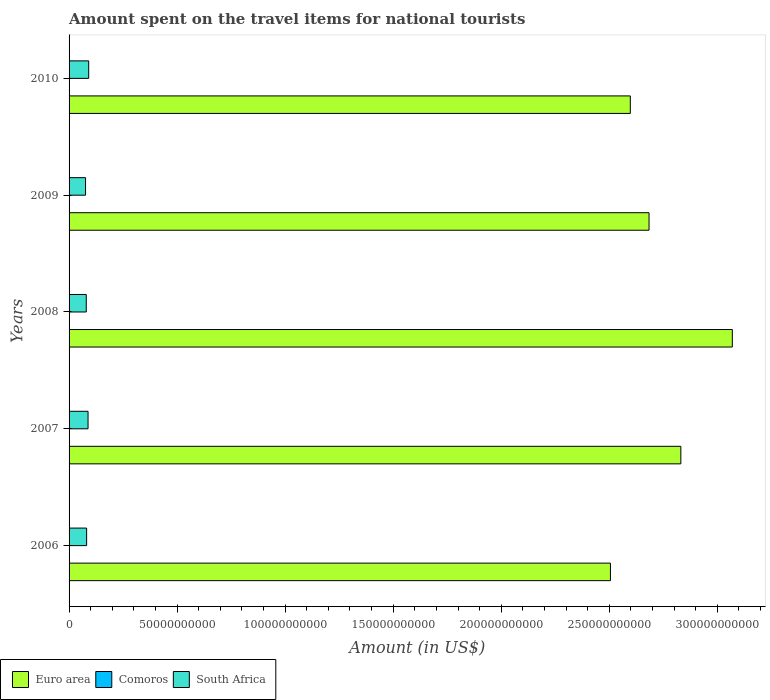How many different coloured bars are there?
Give a very brief answer. 3. How many groups of bars are there?
Offer a terse response. 5. Are the number of bars on each tick of the Y-axis equal?
Your answer should be compact. Yes. How many bars are there on the 1st tick from the top?
Give a very brief answer. 3. What is the label of the 4th group of bars from the top?
Provide a short and direct response. 2007. In how many cases, is the number of bars for a given year not equal to the number of legend labels?
Provide a succinct answer. 0. What is the amount spent on the travel items for national tourists in Comoros in 2010?
Your answer should be very brief. 3.50e+07. Across all years, what is the maximum amount spent on the travel items for national tourists in Comoros?
Provide a succinct answer. 3.70e+07. Across all years, what is the minimum amount spent on the travel items for national tourists in South Africa?
Ensure brevity in your answer.  7.62e+09. In which year was the amount spent on the travel items for national tourists in South Africa minimum?
Offer a terse response. 2009. What is the total amount spent on the travel items for national tourists in South Africa in the graph?
Provide a short and direct response. 4.16e+1. What is the difference between the amount spent on the travel items for national tourists in South Africa in 2006 and that in 2007?
Ensure brevity in your answer.  -6.59e+08. What is the difference between the amount spent on the travel items for national tourists in Euro area in 2009 and the amount spent on the travel items for national tourists in Comoros in 2008?
Ensure brevity in your answer.  2.68e+11. What is the average amount spent on the travel items for national tourists in Comoros per year?
Your response must be concise. 3.22e+07. In the year 2006, what is the difference between the amount spent on the travel items for national tourists in Euro area and amount spent on the travel items for national tourists in South Africa?
Provide a short and direct response. 2.42e+11. In how many years, is the amount spent on the travel items for national tourists in Comoros greater than 230000000000 US$?
Ensure brevity in your answer.  0. What is the ratio of the amount spent on the travel items for national tourists in Comoros in 2007 to that in 2010?
Your response must be concise. 0.86. Is the amount spent on the travel items for national tourists in Euro area in 2009 less than that in 2010?
Give a very brief answer. No. Is the difference between the amount spent on the travel items for national tourists in Euro area in 2006 and 2010 greater than the difference between the amount spent on the travel items for national tourists in South Africa in 2006 and 2010?
Offer a very short reply. No. What is the difference between the highest and the second highest amount spent on the travel items for national tourists in Euro area?
Make the answer very short. 2.38e+1. What is the difference between the highest and the lowest amount spent on the travel items for national tourists in South Africa?
Your answer should be very brief. 1.46e+09. In how many years, is the amount spent on the travel items for national tourists in South Africa greater than the average amount spent on the travel items for national tourists in South Africa taken over all years?
Your response must be concise. 2. Is the sum of the amount spent on the travel items for national tourists in Comoros in 2009 and 2010 greater than the maximum amount spent on the travel items for national tourists in South Africa across all years?
Your answer should be compact. No. What does the 2nd bar from the top in 2006 represents?
Your answer should be compact. Comoros. Is it the case that in every year, the sum of the amount spent on the travel items for national tourists in Comoros and amount spent on the travel items for national tourists in Euro area is greater than the amount spent on the travel items for national tourists in South Africa?
Ensure brevity in your answer.  Yes. How many bars are there?
Offer a very short reply. 15. Are the values on the major ticks of X-axis written in scientific E-notation?
Provide a short and direct response. No. Does the graph contain any zero values?
Provide a short and direct response. No. Does the graph contain grids?
Make the answer very short. No. Where does the legend appear in the graph?
Provide a short and direct response. Bottom left. How many legend labels are there?
Provide a succinct answer. 3. What is the title of the graph?
Ensure brevity in your answer.  Amount spent on the travel items for national tourists. Does "Seychelles" appear as one of the legend labels in the graph?
Offer a very short reply. No. What is the Amount (in US$) in Euro area in 2006?
Provide a short and direct response. 2.51e+11. What is the Amount (in US$) of Comoros in 2006?
Give a very brief answer. 2.70e+07. What is the Amount (in US$) of South Africa in 2006?
Provide a succinct answer. 8.12e+09. What is the Amount (in US$) in Euro area in 2007?
Provide a succinct answer. 2.83e+11. What is the Amount (in US$) of Comoros in 2007?
Provide a succinct answer. 3.00e+07. What is the Amount (in US$) in South Africa in 2007?
Ensure brevity in your answer.  8.78e+09. What is the Amount (in US$) of Euro area in 2008?
Give a very brief answer. 3.07e+11. What is the Amount (in US$) of Comoros in 2008?
Offer a terse response. 3.70e+07. What is the Amount (in US$) of South Africa in 2008?
Your answer should be very brief. 7.96e+09. What is the Amount (in US$) in Euro area in 2009?
Keep it short and to the point. 2.68e+11. What is the Amount (in US$) in Comoros in 2009?
Your answer should be very brief. 3.20e+07. What is the Amount (in US$) of South Africa in 2009?
Your answer should be very brief. 7.62e+09. What is the Amount (in US$) of Euro area in 2010?
Offer a terse response. 2.60e+11. What is the Amount (in US$) in Comoros in 2010?
Your response must be concise. 3.50e+07. What is the Amount (in US$) of South Africa in 2010?
Provide a succinct answer. 9.08e+09. Across all years, what is the maximum Amount (in US$) of Euro area?
Your answer should be compact. 3.07e+11. Across all years, what is the maximum Amount (in US$) of Comoros?
Make the answer very short. 3.70e+07. Across all years, what is the maximum Amount (in US$) in South Africa?
Ensure brevity in your answer.  9.08e+09. Across all years, what is the minimum Amount (in US$) in Euro area?
Provide a short and direct response. 2.51e+11. Across all years, what is the minimum Amount (in US$) of Comoros?
Keep it short and to the point. 2.70e+07. Across all years, what is the minimum Amount (in US$) of South Africa?
Keep it short and to the point. 7.62e+09. What is the total Amount (in US$) of Euro area in the graph?
Offer a very short reply. 1.37e+12. What is the total Amount (in US$) of Comoros in the graph?
Give a very brief answer. 1.61e+08. What is the total Amount (in US$) of South Africa in the graph?
Your answer should be compact. 4.16e+1. What is the difference between the Amount (in US$) of Euro area in 2006 and that in 2007?
Offer a terse response. -3.26e+1. What is the difference between the Amount (in US$) in Comoros in 2006 and that in 2007?
Provide a succinct answer. -3.00e+06. What is the difference between the Amount (in US$) of South Africa in 2006 and that in 2007?
Give a very brief answer. -6.59e+08. What is the difference between the Amount (in US$) of Euro area in 2006 and that in 2008?
Provide a short and direct response. -5.64e+1. What is the difference between the Amount (in US$) in Comoros in 2006 and that in 2008?
Provide a short and direct response. -1.00e+07. What is the difference between the Amount (in US$) in South Africa in 2006 and that in 2008?
Provide a succinct answer. 1.64e+08. What is the difference between the Amount (in US$) of Euro area in 2006 and that in 2009?
Provide a short and direct response. -1.79e+1. What is the difference between the Amount (in US$) in Comoros in 2006 and that in 2009?
Your answer should be very brief. -5.00e+06. What is the difference between the Amount (in US$) in South Africa in 2006 and that in 2009?
Your response must be concise. 4.96e+08. What is the difference between the Amount (in US$) in Euro area in 2006 and that in 2010?
Your answer should be compact. -9.19e+09. What is the difference between the Amount (in US$) of Comoros in 2006 and that in 2010?
Your answer should be very brief. -8.00e+06. What is the difference between the Amount (in US$) in South Africa in 2006 and that in 2010?
Your response must be concise. -9.65e+08. What is the difference between the Amount (in US$) of Euro area in 2007 and that in 2008?
Your response must be concise. -2.38e+1. What is the difference between the Amount (in US$) of Comoros in 2007 and that in 2008?
Offer a terse response. -7.00e+06. What is the difference between the Amount (in US$) in South Africa in 2007 and that in 2008?
Your response must be concise. 8.23e+08. What is the difference between the Amount (in US$) of Euro area in 2007 and that in 2009?
Your answer should be compact. 1.47e+1. What is the difference between the Amount (in US$) of Comoros in 2007 and that in 2009?
Offer a terse response. -2.00e+06. What is the difference between the Amount (in US$) of South Africa in 2007 and that in 2009?
Give a very brief answer. 1.16e+09. What is the difference between the Amount (in US$) in Euro area in 2007 and that in 2010?
Make the answer very short. 2.34e+1. What is the difference between the Amount (in US$) in Comoros in 2007 and that in 2010?
Offer a terse response. -5.00e+06. What is the difference between the Amount (in US$) in South Africa in 2007 and that in 2010?
Your answer should be compact. -3.06e+08. What is the difference between the Amount (in US$) in Euro area in 2008 and that in 2009?
Give a very brief answer. 3.85e+1. What is the difference between the Amount (in US$) in South Africa in 2008 and that in 2009?
Make the answer very short. 3.32e+08. What is the difference between the Amount (in US$) of Euro area in 2008 and that in 2010?
Your response must be concise. 4.72e+1. What is the difference between the Amount (in US$) in Comoros in 2008 and that in 2010?
Provide a succinct answer. 2.00e+06. What is the difference between the Amount (in US$) in South Africa in 2008 and that in 2010?
Provide a succinct answer. -1.13e+09. What is the difference between the Amount (in US$) in Euro area in 2009 and that in 2010?
Your answer should be compact. 8.67e+09. What is the difference between the Amount (in US$) of South Africa in 2009 and that in 2010?
Provide a short and direct response. -1.46e+09. What is the difference between the Amount (in US$) in Euro area in 2006 and the Amount (in US$) in Comoros in 2007?
Provide a short and direct response. 2.51e+11. What is the difference between the Amount (in US$) in Euro area in 2006 and the Amount (in US$) in South Africa in 2007?
Ensure brevity in your answer.  2.42e+11. What is the difference between the Amount (in US$) of Comoros in 2006 and the Amount (in US$) of South Africa in 2007?
Provide a short and direct response. -8.75e+09. What is the difference between the Amount (in US$) of Euro area in 2006 and the Amount (in US$) of Comoros in 2008?
Your answer should be very brief. 2.50e+11. What is the difference between the Amount (in US$) in Euro area in 2006 and the Amount (in US$) in South Africa in 2008?
Your response must be concise. 2.43e+11. What is the difference between the Amount (in US$) in Comoros in 2006 and the Amount (in US$) in South Africa in 2008?
Keep it short and to the point. -7.93e+09. What is the difference between the Amount (in US$) of Euro area in 2006 and the Amount (in US$) of Comoros in 2009?
Provide a short and direct response. 2.50e+11. What is the difference between the Amount (in US$) in Euro area in 2006 and the Amount (in US$) in South Africa in 2009?
Provide a succinct answer. 2.43e+11. What is the difference between the Amount (in US$) of Comoros in 2006 and the Amount (in US$) of South Africa in 2009?
Your answer should be very brief. -7.60e+09. What is the difference between the Amount (in US$) in Euro area in 2006 and the Amount (in US$) in Comoros in 2010?
Keep it short and to the point. 2.50e+11. What is the difference between the Amount (in US$) in Euro area in 2006 and the Amount (in US$) in South Africa in 2010?
Provide a short and direct response. 2.41e+11. What is the difference between the Amount (in US$) in Comoros in 2006 and the Amount (in US$) in South Africa in 2010?
Offer a terse response. -9.06e+09. What is the difference between the Amount (in US$) in Euro area in 2007 and the Amount (in US$) in Comoros in 2008?
Your answer should be very brief. 2.83e+11. What is the difference between the Amount (in US$) in Euro area in 2007 and the Amount (in US$) in South Africa in 2008?
Offer a terse response. 2.75e+11. What is the difference between the Amount (in US$) in Comoros in 2007 and the Amount (in US$) in South Africa in 2008?
Your response must be concise. -7.93e+09. What is the difference between the Amount (in US$) of Euro area in 2007 and the Amount (in US$) of Comoros in 2009?
Give a very brief answer. 2.83e+11. What is the difference between the Amount (in US$) of Euro area in 2007 and the Amount (in US$) of South Africa in 2009?
Offer a very short reply. 2.75e+11. What is the difference between the Amount (in US$) in Comoros in 2007 and the Amount (in US$) in South Africa in 2009?
Provide a succinct answer. -7.59e+09. What is the difference between the Amount (in US$) in Euro area in 2007 and the Amount (in US$) in Comoros in 2010?
Your answer should be compact. 2.83e+11. What is the difference between the Amount (in US$) of Euro area in 2007 and the Amount (in US$) of South Africa in 2010?
Offer a very short reply. 2.74e+11. What is the difference between the Amount (in US$) in Comoros in 2007 and the Amount (in US$) in South Africa in 2010?
Offer a terse response. -9.06e+09. What is the difference between the Amount (in US$) in Euro area in 2008 and the Amount (in US$) in Comoros in 2009?
Offer a very short reply. 3.07e+11. What is the difference between the Amount (in US$) in Euro area in 2008 and the Amount (in US$) in South Africa in 2009?
Your answer should be very brief. 2.99e+11. What is the difference between the Amount (in US$) of Comoros in 2008 and the Amount (in US$) of South Africa in 2009?
Make the answer very short. -7.59e+09. What is the difference between the Amount (in US$) in Euro area in 2008 and the Amount (in US$) in Comoros in 2010?
Give a very brief answer. 3.07e+11. What is the difference between the Amount (in US$) in Euro area in 2008 and the Amount (in US$) in South Africa in 2010?
Your answer should be compact. 2.98e+11. What is the difference between the Amount (in US$) in Comoros in 2008 and the Amount (in US$) in South Africa in 2010?
Provide a short and direct response. -9.05e+09. What is the difference between the Amount (in US$) of Euro area in 2009 and the Amount (in US$) of Comoros in 2010?
Provide a succinct answer. 2.68e+11. What is the difference between the Amount (in US$) of Euro area in 2009 and the Amount (in US$) of South Africa in 2010?
Your answer should be very brief. 2.59e+11. What is the difference between the Amount (in US$) of Comoros in 2009 and the Amount (in US$) of South Africa in 2010?
Ensure brevity in your answer.  -9.05e+09. What is the average Amount (in US$) in Euro area per year?
Offer a very short reply. 2.74e+11. What is the average Amount (in US$) in Comoros per year?
Provide a short and direct response. 3.22e+07. What is the average Amount (in US$) of South Africa per year?
Provide a succinct answer. 8.31e+09. In the year 2006, what is the difference between the Amount (in US$) in Euro area and Amount (in US$) in Comoros?
Provide a short and direct response. 2.51e+11. In the year 2006, what is the difference between the Amount (in US$) of Euro area and Amount (in US$) of South Africa?
Offer a terse response. 2.42e+11. In the year 2006, what is the difference between the Amount (in US$) of Comoros and Amount (in US$) of South Africa?
Offer a very short reply. -8.09e+09. In the year 2007, what is the difference between the Amount (in US$) in Euro area and Amount (in US$) in Comoros?
Your answer should be compact. 2.83e+11. In the year 2007, what is the difference between the Amount (in US$) in Euro area and Amount (in US$) in South Africa?
Give a very brief answer. 2.74e+11. In the year 2007, what is the difference between the Amount (in US$) in Comoros and Amount (in US$) in South Africa?
Your response must be concise. -8.75e+09. In the year 2008, what is the difference between the Amount (in US$) of Euro area and Amount (in US$) of Comoros?
Keep it short and to the point. 3.07e+11. In the year 2008, what is the difference between the Amount (in US$) in Euro area and Amount (in US$) in South Africa?
Your answer should be compact. 2.99e+11. In the year 2008, what is the difference between the Amount (in US$) in Comoros and Amount (in US$) in South Africa?
Offer a very short reply. -7.92e+09. In the year 2009, what is the difference between the Amount (in US$) in Euro area and Amount (in US$) in Comoros?
Ensure brevity in your answer.  2.68e+11. In the year 2009, what is the difference between the Amount (in US$) of Euro area and Amount (in US$) of South Africa?
Keep it short and to the point. 2.61e+11. In the year 2009, what is the difference between the Amount (in US$) of Comoros and Amount (in US$) of South Africa?
Offer a terse response. -7.59e+09. In the year 2010, what is the difference between the Amount (in US$) in Euro area and Amount (in US$) in Comoros?
Your answer should be compact. 2.60e+11. In the year 2010, what is the difference between the Amount (in US$) of Euro area and Amount (in US$) of South Africa?
Give a very brief answer. 2.51e+11. In the year 2010, what is the difference between the Amount (in US$) in Comoros and Amount (in US$) in South Africa?
Offer a very short reply. -9.05e+09. What is the ratio of the Amount (in US$) in Euro area in 2006 to that in 2007?
Offer a very short reply. 0.88. What is the ratio of the Amount (in US$) in South Africa in 2006 to that in 2007?
Your answer should be compact. 0.92. What is the ratio of the Amount (in US$) of Euro area in 2006 to that in 2008?
Give a very brief answer. 0.82. What is the ratio of the Amount (in US$) in Comoros in 2006 to that in 2008?
Your answer should be compact. 0.73. What is the ratio of the Amount (in US$) of South Africa in 2006 to that in 2008?
Your response must be concise. 1.02. What is the ratio of the Amount (in US$) of Euro area in 2006 to that in 2009?
Make the answer very short. 0.93. What is the ratio of the Amount (in US$) in Comoros in 2006 to that in 2009?
Provide a short and direct response. 0.84. What is the ratio of the Amount (in US$) in South Africa in 2006 to that in 2009?
Give a very brief answer. 1.07. What is the ratio of the Amount (in US$) of Euro area in 2006 to that in 2010?
Keep it short and to the point. 0.96. What is the ratio of the Amount (in US$) of Comoros in 2006 to that in 2010?
Offer a terse response. 0.77. What is the ratio of the Amount (in US$) in South Africa in 2006 to that in 2010?
Your response must be concise. 0.89. What is the ratio of the Amount (in US$) of Euro area in 2007 to that in 2008?
Make the answer very short. 0.92. What is the ratio of the Amount (in US$) of Comoros in 2007 to that in 2008?
Your answer should be very brief. 0.81. What is the ratio of the Amount (in US$) of South Africa in 2007 to that in 2008?
Keep it short and to the point. 1.1. What is the ratio of the Amount (in US$) in Euro area in 2007 to that in 2009?
Provide a short and direct response. 1.05. What is the ratio of the Amount (in US$) in Comoros in 2007 to that in 2009?
Make the answer very short. 0.94. What is the ratio of the Amount (in US$) in South Africa in 2007 to that in 2009?
Your answer should be compact. 1.15. What is the ratio of the Amount (in US$) in Euro area in 2007 to that in 2010?
Offer a very short reply. 1.09. What is the ratio of the Amount (in US$) in South Africa in 2007 to that in 2010?
Ensure brevity in your answer.  0.97. What is the ratio of the Amount (in US$) in Euro area in 2008 to that in 2009?
Ensure brevity in your answer.  1.14. What is the ratio of the Amount (in US$) of Comoros in 2008 to that in 2009?
Provide a short and direct response. 1.16. What is the ratio of the Amount (in US$) of South Africa in 2008 to that in 2009?
Ensure brevity in your answer.  1.04. What is the ratio of the Amount (in US$) in Euro area in 2008 to that in 2010?
Ensure brevity in your answer.  1.18. What is the ratio of the Amount (in US$) of Comoros in 2008 to that in 2010?
Keep it short and to the point. 1.06. What is the ratio of the Amount (in US$) of South Africa in 2008 to that in 2010?
Make the answer very short. 0.88. What is the ratio of the Amount (in US$) in Euro area in 2009 to that in 2010?
Keep it short and to the point. 1.03. What is the ratio of the Amount (in US$) in Comoros in 2009 to that in 2010?
Offer a very short reply. 0.91. What is the ratio of the Amount (in US$) in South Africa in 2009 to that in 2010?
Offer a terse response. 0.84. What is the difference between the highest and the second highest Amount (in US$) in Euro area?
Ensure brevity in your answer.  2.38e+1. What is the difference between the highest and the second highest Amount (in US$) of South Africa?
Make the answer very short. 3.06e+08. What is the difference between the highest and the lowest Amount (in US$) of Euro area?
Keep it short and to the point. 5.64e+1. What is the difference between the highest and the lowest Amount (in US$) in South Africa?
Provide a short and direct response. 1.46e+09. 